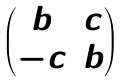<formula> <loc_0><loc_0><loc_500><loc_500>\begin{pmatrix} b & c \\ - c & b \end{pmatrix}</formula> 